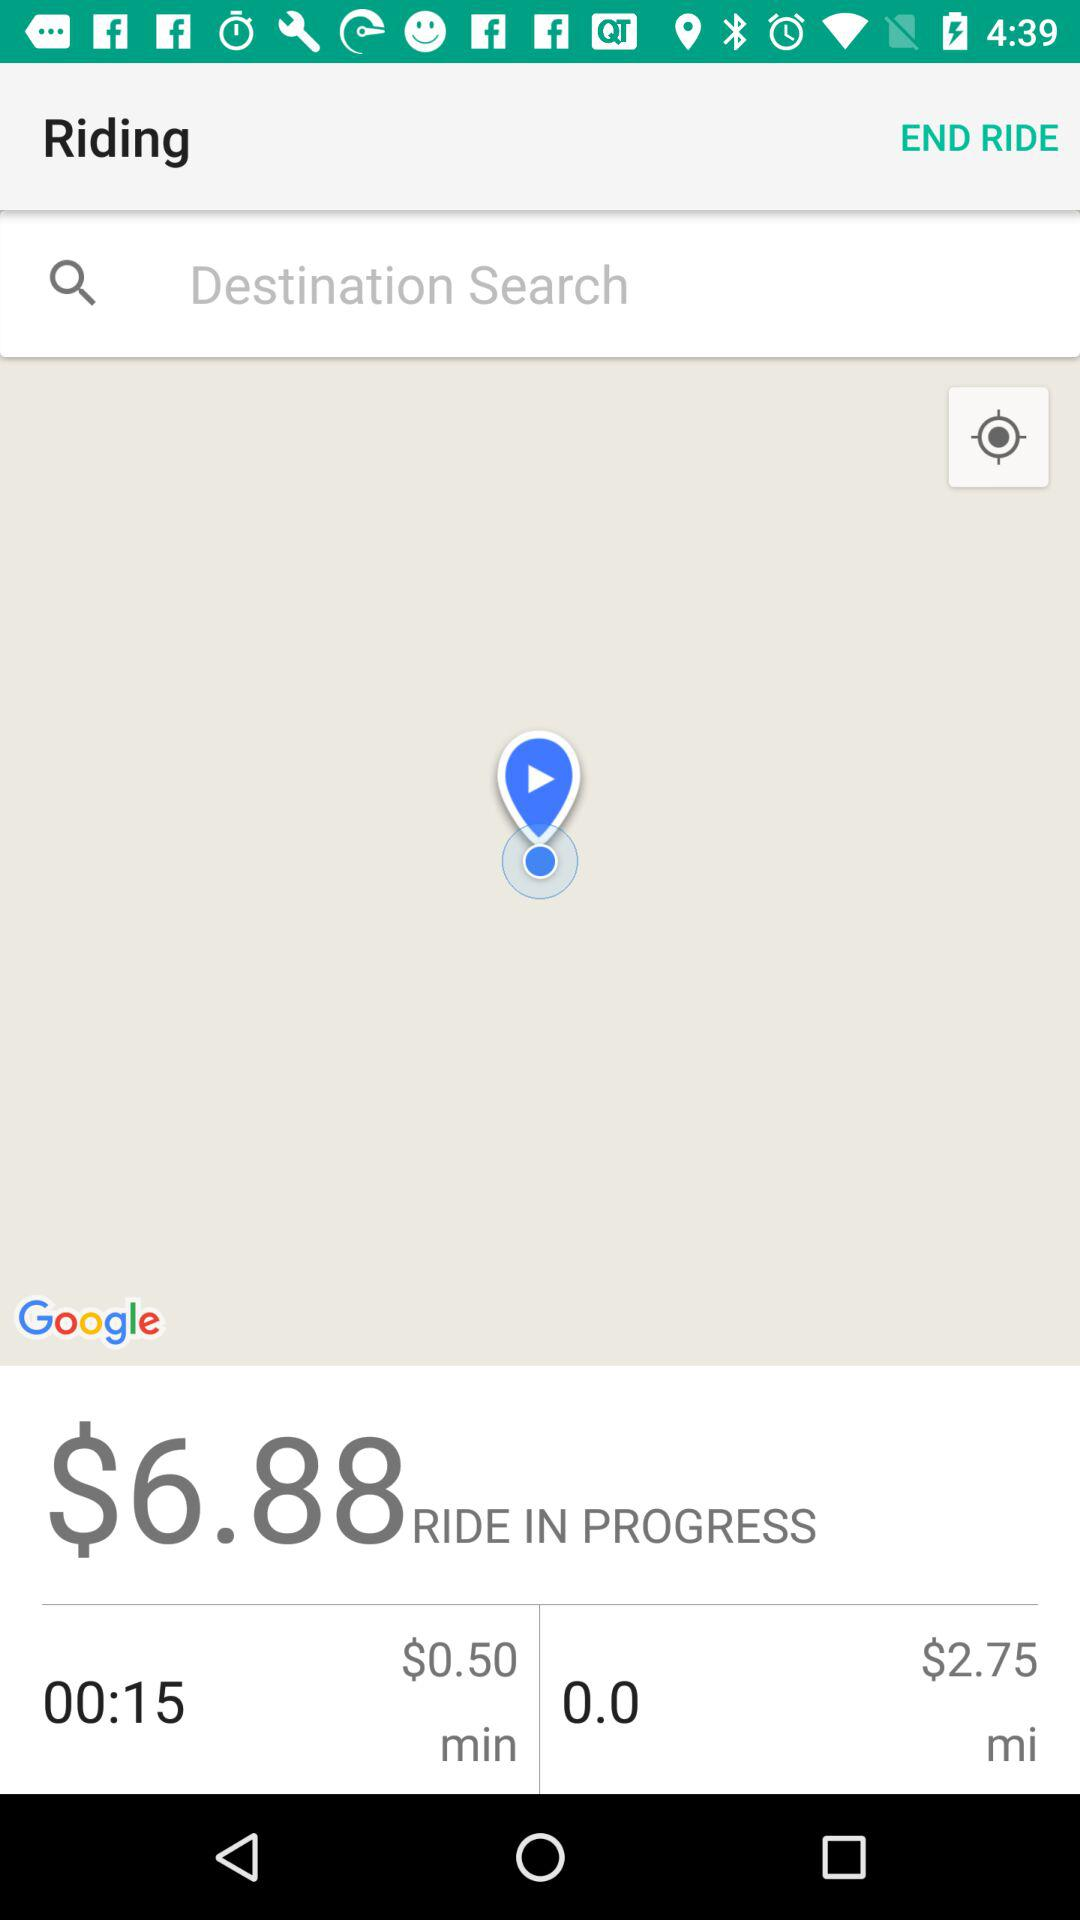What is the given value? The given value is $6.88. 